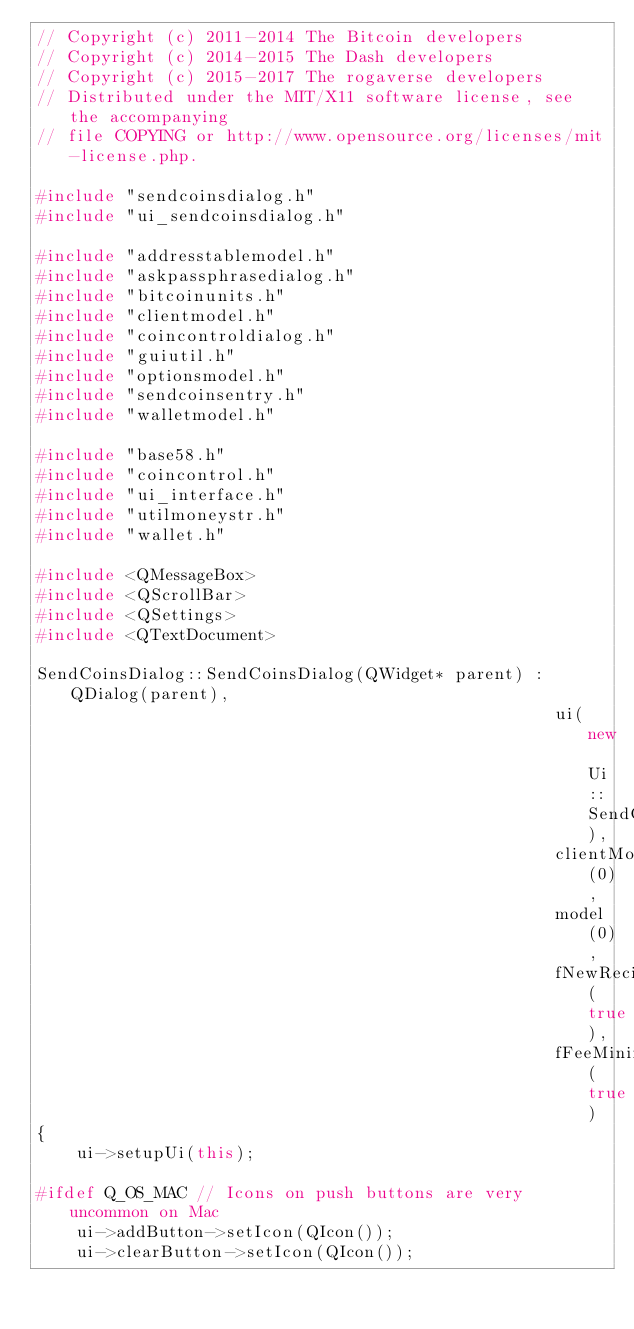<code> <loc_0><loc_0><loc_500><loc_500><_C++_>// Copyright (c) 2011-2014 The Bitcoin developers
// Copyright (c) 2014-2015 The Dash developers
// Copyright (c) 2015-2017 The rogaverse developers
// Distributed under the MIT/X11 software license, see the accompanying
// file COPYING or http://www.opensource.org/licenses/mit-license.php.

#include "sendcoinsdialog.h"
#include "ui_sendcoinsdialog.h"

#include "addresstablemodel.h"
#include "askpassphrasedialog.h"
#include "bitcoinunits.h"
#include "clientmodel.h"
#include "coincontroldialog.h"
#include "guiutil.h"
#include "optionsmodel.h"
#include "sendcoinsentry.h"
#include "walletmodel.h"

#include "base58.h"
#include "coincontrol.h"
#include "ui_interface.h"
#include "utilmoneystr.h"
#include "wallet.h"

#include <QMessageBox>
#include <QScrollBar>
#include <QSettings>
#include <QTextDocument>

SendCoinsDialog::SendCoinsDialog(QWidget* parent) : QDialog(parent),
                                                    ui(new Ui::SendCoinsDialog),
                                                    clientModel(0),
                                                    model(0),
                                                    fNewRecipientAllowed(true),
                                                    fFeeMinimized(true)
{
    ui->setupUi(this);

#ifdef Q_OS_MAC // Icons on push buttons are very uncommon on Mac
    ui->addButton->setIcon(QIcon());
    ui->clearButton->setIcon(QIcon());</code> 